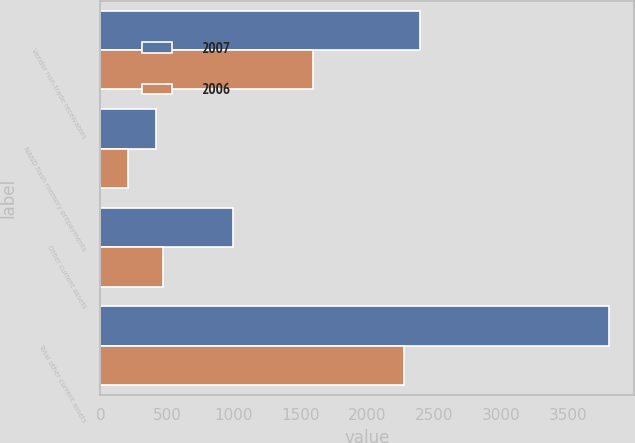Convert chart to OTSL. <chart><loc_0><loc_0><loc_500><loc_500><stacked_bar_chart><ecel><fcel>Vendor non-trade receivables<fcel>NAND flash memory prepayments<fcel>Other current assets<fcel>Total other current assets<nl><fcel>2007<fcel>2392<fcel>417<fcel>996<fcel>3805<nl><fcel>2006<fcel>1593<fcel>208<fcel>469<fcel>2270<nl></chart> 